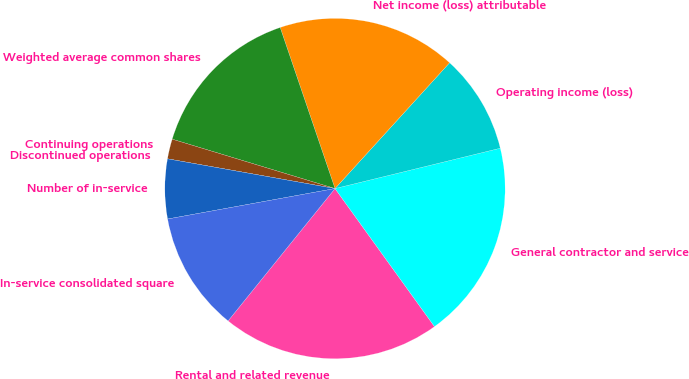Convert chart to OTSL. <chart><loc_0><loc_0><loc_500><loc_500><pie_chart><fcel>Rental and related revenue<fcel>General contractor and service<fcel>Operating income (loss)<fcel>Net income (loss) attributable<fcel>Weighted average common shares<fcel>Continuing operations<fcel>Discontinued operations<fcel>Number of in-service<fcel>In-service consolidated square<nl><fcel>20.75%<fcel>18.87%<fcel>9.43%<fcel>16.98%<fcel>15.09%<fcel>1.89%<fcel>0.0%<fcel>5.66%<fcel>11.32%<nl></chart> 